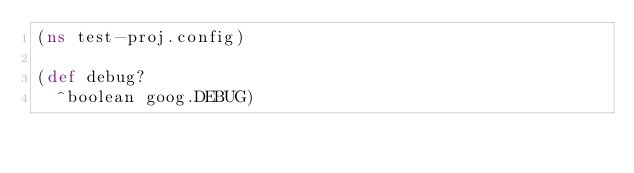<code> <loc_0><loc_0><loc_500><loc_500><_Clojure_>(ns test-proj.config)

(def debug?
  ^boolean goog.DEBUG)
</code> 